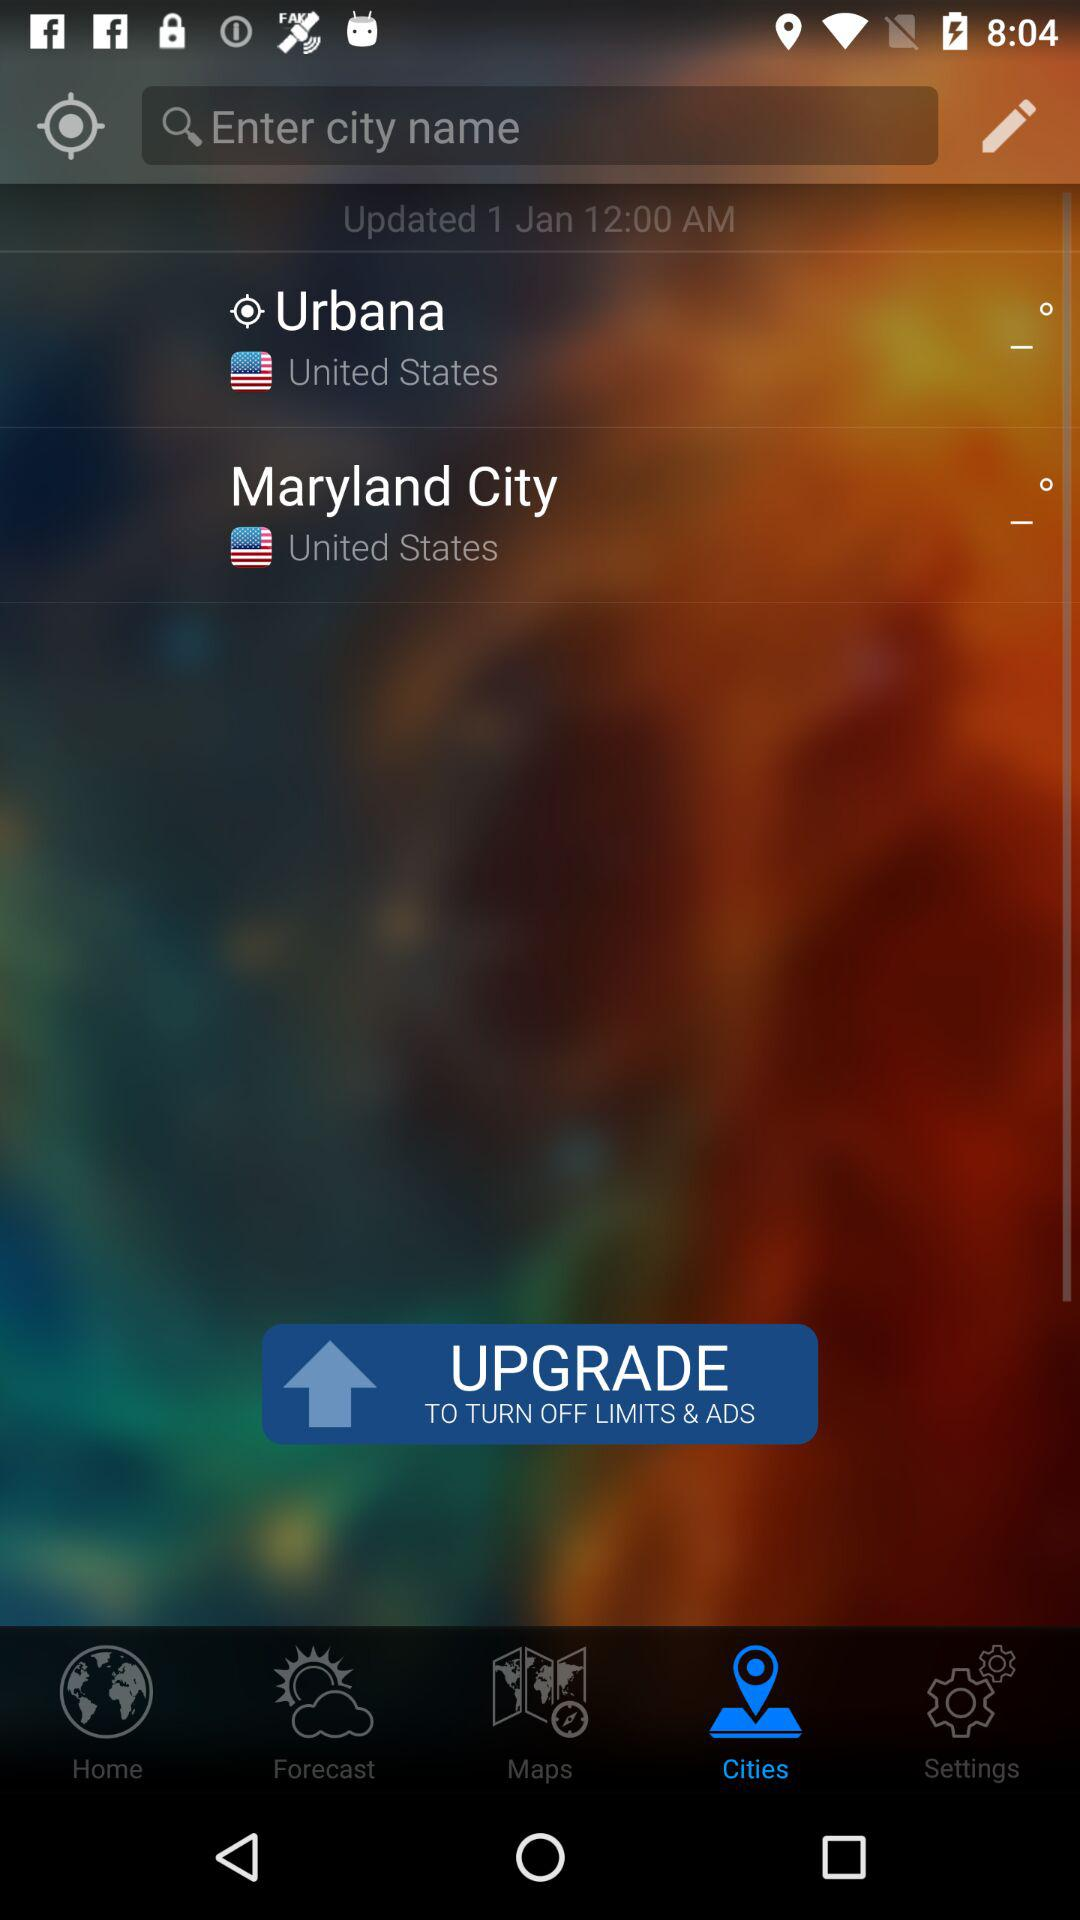When was the "Cities" tab last updated and at what time? The tab was last updated on January 1 at 12 AM. 